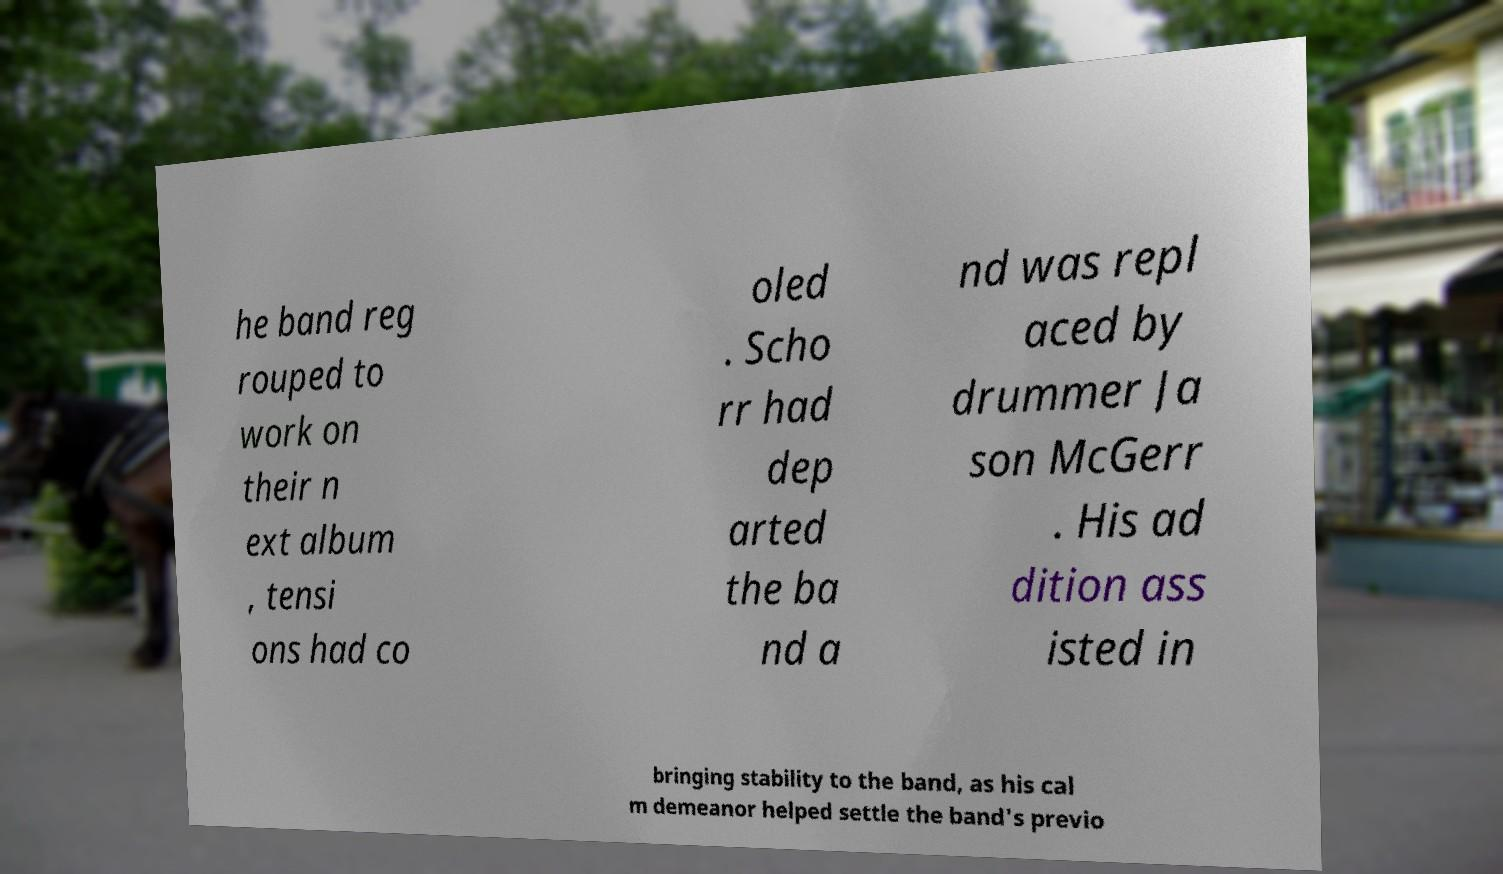Can you accurately transcribe the text from the provided image for me? he band reg rouped to work on their n ext album , tensi ons had co oled . Scho rr had dep arted the ba nd a nd was repl aced by drummer Ja son McGerr . His ad dition ass isted in bringing stability to the band, as his cal m demeanor helped settle the band's previo 